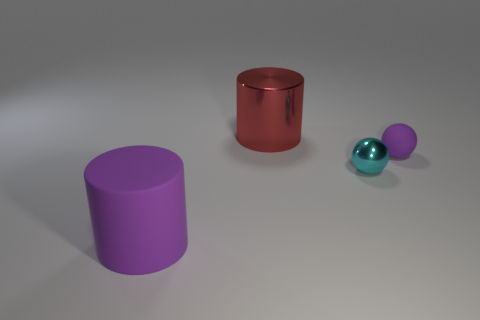Add 4 cylinders. How many objects exist? 8 Subtract all purple cylinders. How many cylinders are left? 1 Subtract 2 balls. How many balls are left? 0 Add 4 tiny gray rubber spheres. How many tiny gray rubber spheres exist? 4 Subtract 0 brown blocks. How many objects are left? 4 Subtract all yellow spheres. Subtract all brown cylinders. How many spheres are left? 2 Subtract all red cubes. How many purple spheres are left? 1 Subtract all large green things. Subtract all large matte cylinders. How many objects are left? 3 Add 4 rubber balls. How many rubber balls are left? 5 